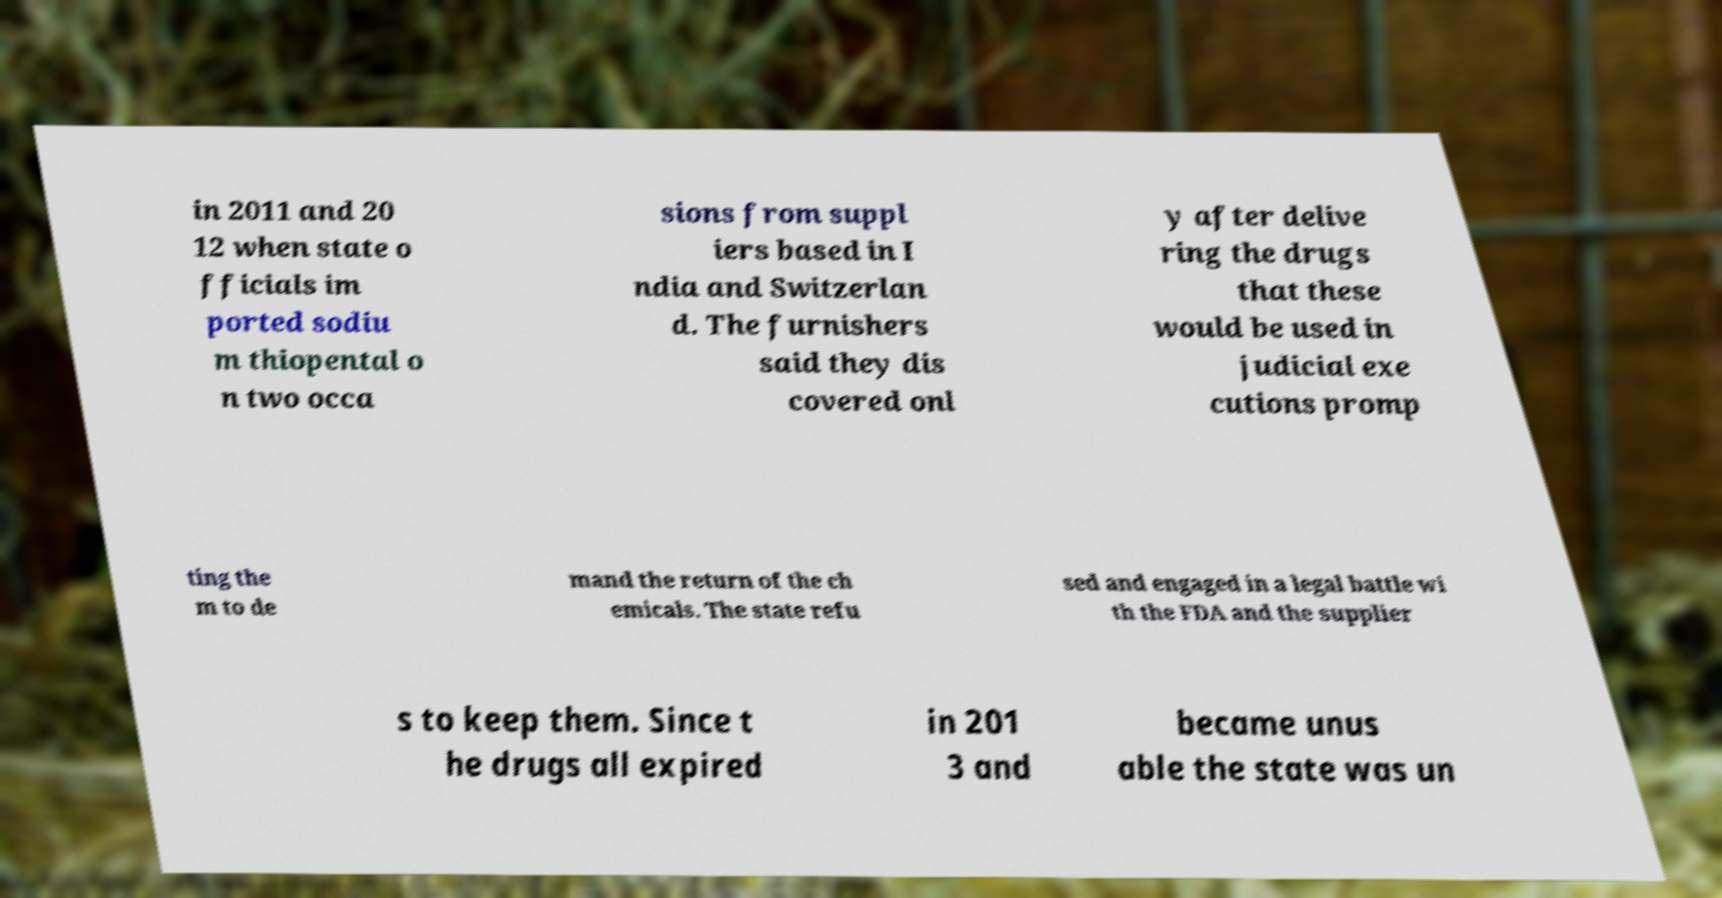Please identify and transcribe the text found in this image. in 2011 and 20 12 when state o fficials im ported sodiu m thiopental o n two occa sions from suppl iers based in I ndia and Switzerlan d. The furnishers said they dis covered onl y after delive ring the drugs that these would be used in judicial exe cutions promp ting the m to de mand the return of the ch emicals. The state refu sed and engaged in a legal battle wi th the FDA and the supplier s to keep them. Since t he drugs all expired in 201 3 and became unus able the state was un 